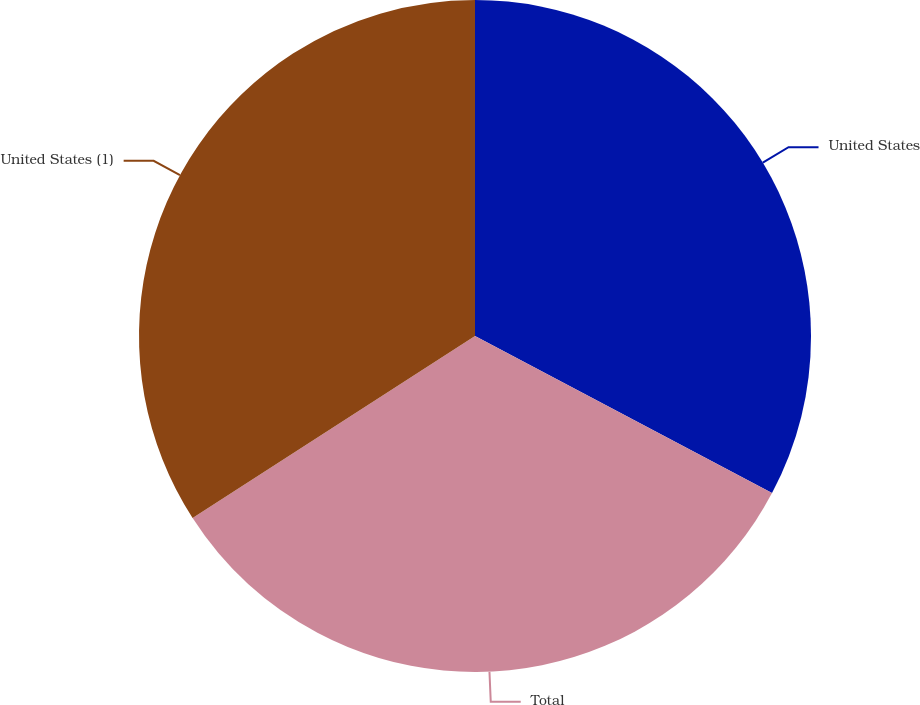Convert chart. <chart><loc_0><loc_0><loc_500><loc_500><pie_chart><fcel>United States<fcel>Total<fcel>United States (1)<nl><fcel>32.74%<fcel>33.14%<fcel>34.11%<nl></chart> 